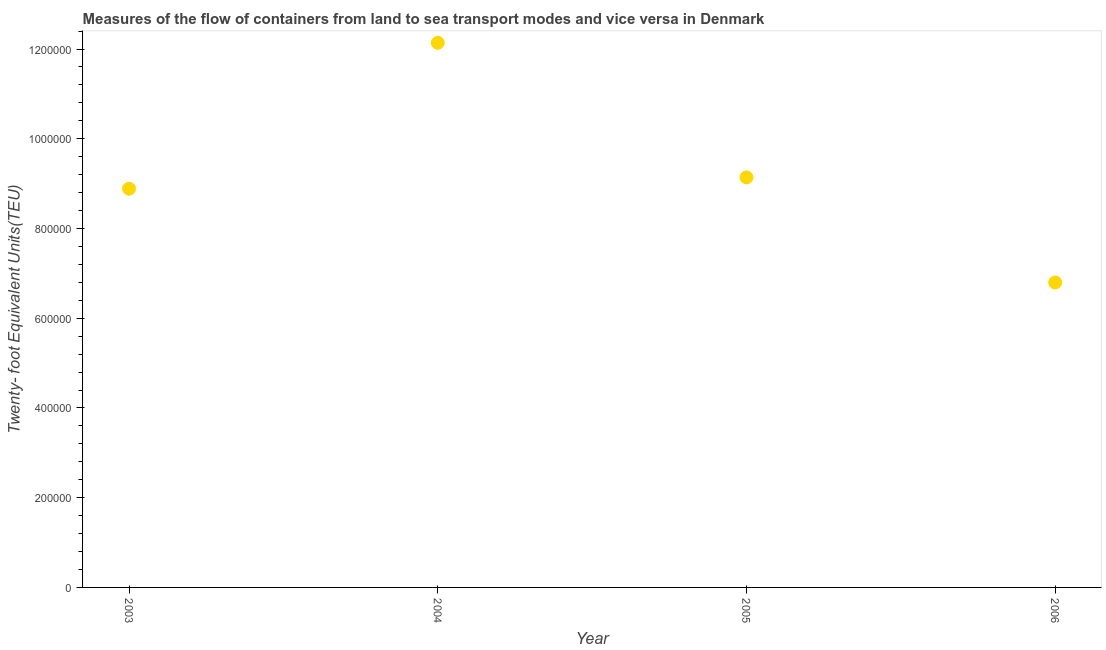What is the container port traffic in 2005?
Offer a very short reply. 9.14e+05. Across all years, what is the maximum container port traffic?
Your answer should be very brief. 1.21e+06. Across all years, what is the minimum container port traffic?
Your answer should be very brief. 6.80e+05. In which year was the container port traffic maximum?
Offer a very short reply. 2004. What is the sum of the container port traffic?
Your response must be concise. 3.70e+06. What is the difference between the container port traffic in 2004 and 2006?
Your answer should be compact. 5.34e+05. What is the average container port traffic per year?
Your answer should be compact. 9.24e+05. What is the median container port traffic?
Provide a short and direct response. 9.01e+05. What is the ratio of the container port traffic in 2004 to that in 2005?
Ensure brevity in your answer.  1.33. Is the container port traffic in 2005 less than that in 2006?
Give a very brief answer. No. What is the difference between the highest and the second highest container port traffic?
Provide a short and direct response. 3.00e+05. What is the difference between the highest and the lowest container port traffic?
Keep it short and to the point. 5.34e+05. Does the container port traffic monotonically increase over the years?
Provide a short and direct response. No. How many years are there in the graph?
Offer a very short reply. 4. What is the difference between two consecutive major ticks on the Y-axis?
Offer a very short reply. 2.00e+05. Are the values on the major ticks of Y-axis written in scientific E-notation?
Your answer should be very brief. No. Does the graph contain any zero values?
Offer a very short reply. No. Does the graph contain grids?
Keep it short and to the point. No. What is the title of the graph?
Provide a short and direct response. Measures of the flow of containers from land to sea transport modes and vice versa in Denmark. What is the label or title of the X-axis?
Make the answer very short. Year. What is the label or title of the Y-axis?
Offer a terse response. Twenty- foot Equivalent Units(TEU). What is the Twenty- foot Equivalent Units(TEU) in 2003?
Offer a terse response. 8.89e+05. What is the Twenty- foot Equivalent Units(TEU) in 2004?
Ensure brevity in your answer.  1.21e+06. What is the Twenty- foot Equivalent Units(TEU) in 2005?
Your answer should be compact. 9.14e+05. What is the Twenty- foot Equivalent Units(TEU) in 2006?
Ensure brevity in your answer.  6.80e+05. What is the difference between the Twenty- foot Equivalent Units(TEU) in 2003 and 2004?
Your answer should be very brief. -3.25e+05. What is the difference between the Twenty- foot Equivalent Units(TEU) in 2003 and 2005?
Ensure brevity in your answer.  -2.52e+04. What is the difference between the Twenty- foot Equivalent Units(TEU) in 2003 and 2006?
Offer a very short reply. 2.09e+05. What is the difference between the Twenty- foot Equivalent Units(TEU) in 2004 and 2005?
Keep it short and to the point. 3.00e+05. What is the difference between the Twenty- foot Equivalent Units(TEU) in 2004 and 2006?
Offer a very short reply. 5.34e+05. What is the difference between the Twenty- foot Equivalent Units(TEU) in 2005 and 2006?
Your response must be concise. 2.34e+05. What is the ratio of the Twenty- foot Equivalent Units(TEU) in 2003 to that in 2004?
Your response must be concise. 0.73. What is the ratio of the Twenty- foot Equivalent Units(TEU) in 2003 to that in 2005?
Provide a short and direct response. 0.97. What is the ratio of the Twenty- foot Equivalent Units(TEU) in 2003 to that in 2006?
Offer a terse response. 1.31. What is the ratio of the Twenty- foot Equivalent Units(TEU) in 2004 to that in 2005?
Give a very brief answer. 1.33. What is the ratio of the Twenty- foot Equivalent Units(TEU) in 2004 to that in 2006?
Keep it short and to the point. 1.79. What is the ratio of the Twenty- foot Equivalent Units(TEU) in 2005 to that in 2006?
Provide a short and direct response. 1.34. 